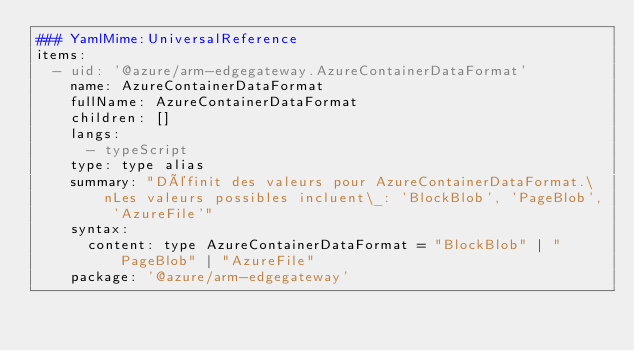<code> <loc_0><loc_0><loc_500><loc_500><_YAML_>### YamlMime:UniversalReference
items:
  - uid: '@azure/arm-edgegateway.AzureContainerDataFormat'
    name: AzureContainerDataFormat
    fullName: AzureContainerDataFormat
    children: []
    langs:
      - typeScript
    type: type alias
    summary: "Définit des valeurs pour AzureContainerDataFormat.\nLes valeurs possibles incluent\_: 'BlockBlob', 'PageBlob', 'AzureFile'"
    syntax:
      content: type AzureContainerDataFormat = "BlockBlob" | "PageBlob" | "AzureFile"
    package: '@azure/arm-edgegateway'</code> 